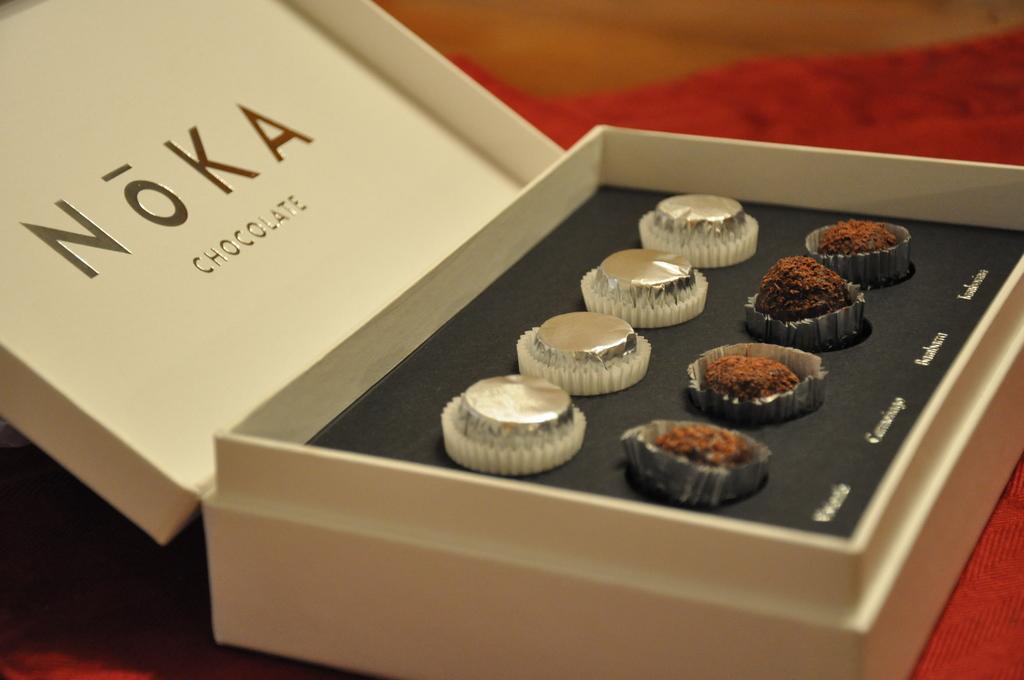Can you describe this image briefly? This looks like a chocolate box with the chocolates in it. I think this is a cloth, which is red in color. The background looks blurry. 